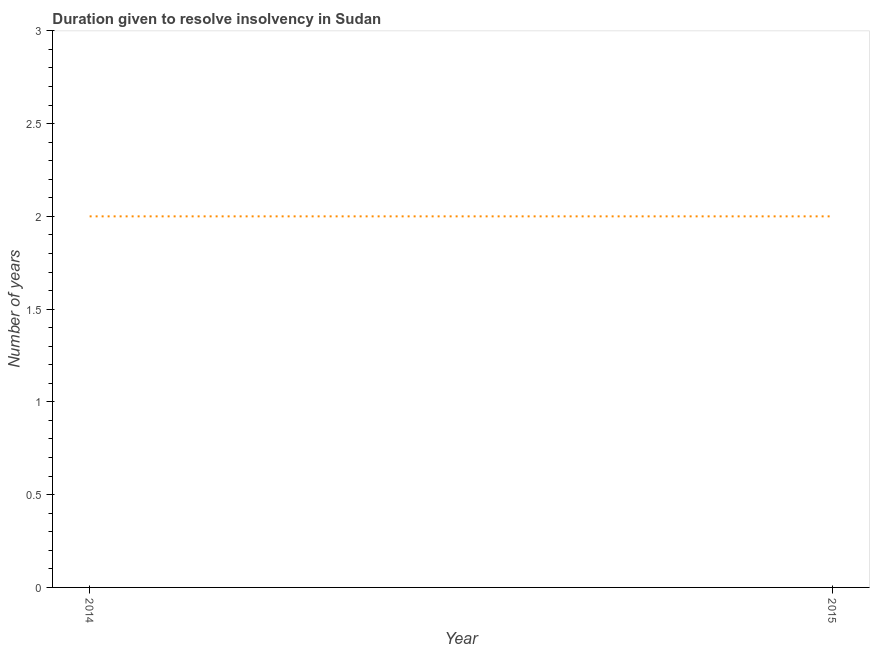What is the number of years to resolve insolvency in 2014?
Ensure brevity in your answer.  2. Across all years, what is the maximum number of years to resolve insolvency?
Keep it short and to the point. 2. Across all years, what is the minimum number of years to resolve insolvency?
Your answer should be very brief. 2. In which year was the number of years to resolve insolvency maximum?
Keep it short and to the point. 2014. What is the sum of the number of years to resolve insolvency?
Make the answer very short. 4. What is the average number of years to resolve insolvency per year?
Your response must be concise. 2. In how many years, is the number of years to resolve insolvency greater than 1.3 ?
Provide a succinct answer. 2. Do a majority of the years between 2015 and 2014 (inclusive) have number of years to resolve insolvency greater than 1.9 ?
Your response must be concise. No. What is the ratio of the number of years to resolve insolvency in 2014 to that in 2015?
Your answer should be very brief. 1. Does the number of years to resolve insolvency monotonically increase over the years?
Give a very brief answer. No. Does the graph contain any zero values?
Your answer should be compact. No. What is the title of the graph?
Your answer should be compact. Duration given to resolve insolvency in Sudan. What is the label or title of the Y-axis?
Provide a short and direct response. Number of years. What is the ratio of the Number of years in 2014 to that in 2015?
Your answer should be very brief. 1. 